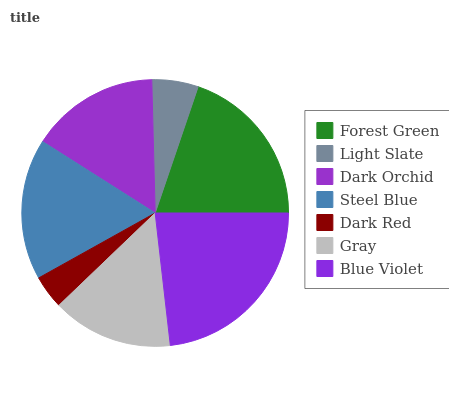Is Dark Red the minimum?
Answer yes or no. Yes. Is Blue Violet the maximum?
Answer yes or no. Yes. Is Light Slate the minimum?
Answer yes or no. No. Is Light Slate the maximum?
Answer yes or no. No. Is Forest Green greater than Light Slate?
Answer yes or no. Yes. Is Light Slate less than Forest Green?
Answer yes or no. Yes. Is Light Slate greater than Forest Green?
Answer yes or no. No. Is Forest Green less than Light Slate?
Answer yes or no. No. Is Dark Orchid the high median?
Answer yes or no. Yes. Is Dark Orchid the low median?
Answer yes or no. Yes. Is Dark Red the high median?
Answer yes or no. No. Is Gray the low median?
Answer yes or no. No. 